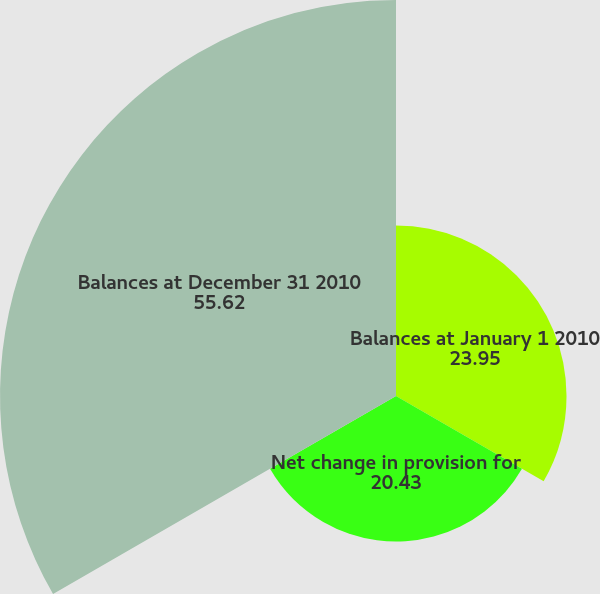<chart> <loc_0><loc_0><loc_500><loc_500><pie_chart><fcel>Balances at January 1 2010<fcel>Net change in provision for<fcel>Balances at December 31 2010<nl><fcel>23.95%<fcel>20.43%<fcel>55.62%<nl></chart> 